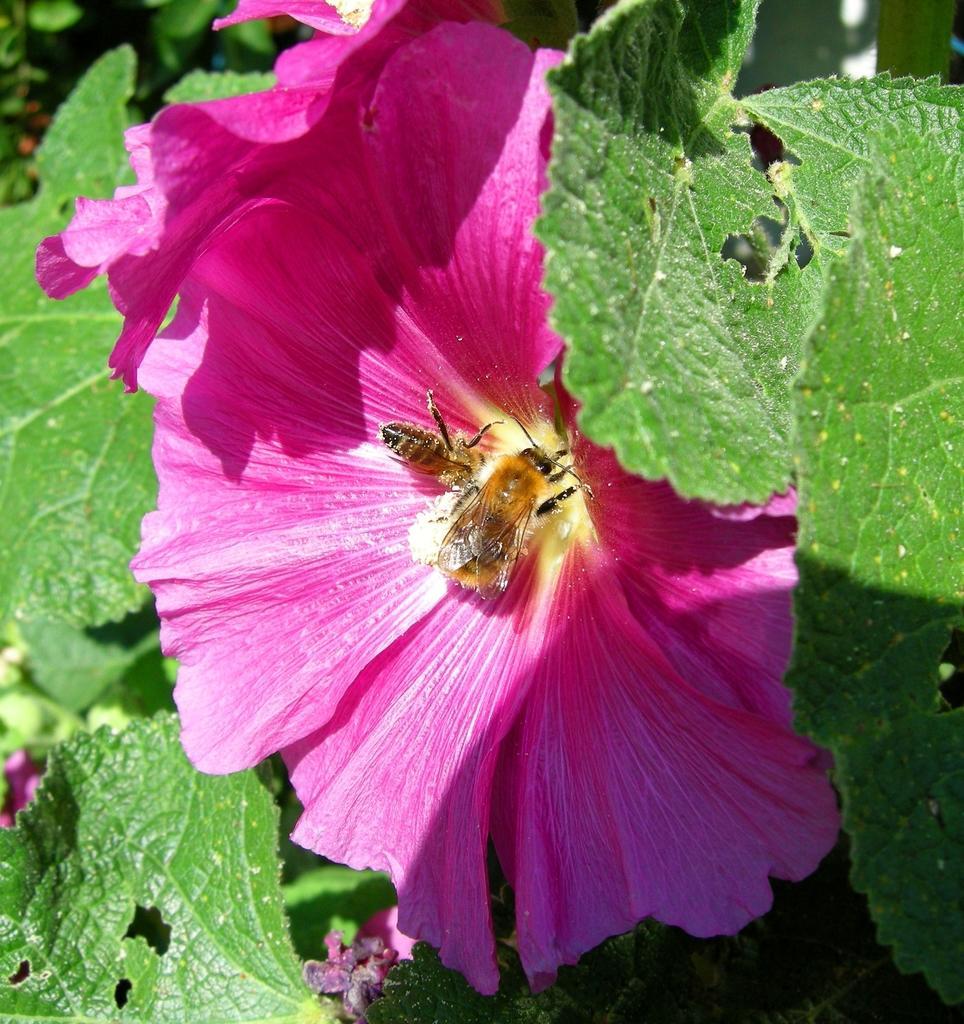Could you give a brief overview of what you see in this image? In the middle of this image, there are two insects on the surface of a pink color flower. Beside this flower, there is another pink color flower of a tree, which is having pink color flowers and green color leaves. In the background, there are green color leaves. 